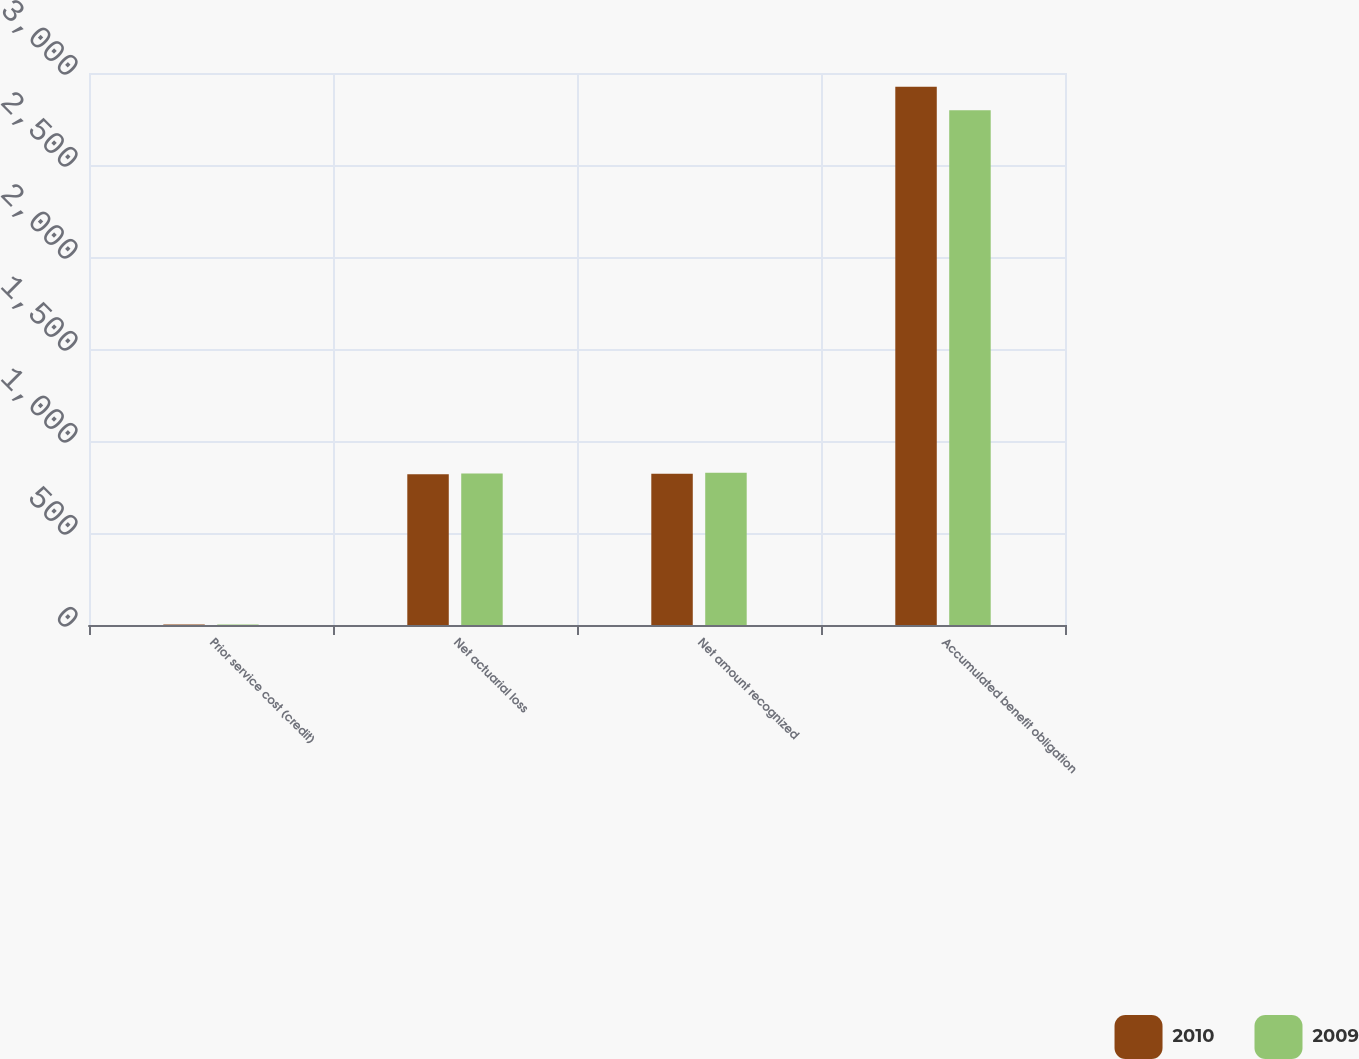Convert chart. <chart><loc_0><loc_0><loc_500><loc_500><stacked_bar_chart><ecel><fcel>Prior service cost (credit)<fcel>Net actuarial loss<fcel>Net amount recognized<fcel>Accumulated benefit obligation<nl><fcel>2010<fcel>3<fcel>819<fcel>822<fcel>2925<nl><fcel>2009<fcel>3<fcel>824<fcel>827<fcel>2798<nl></chart> 